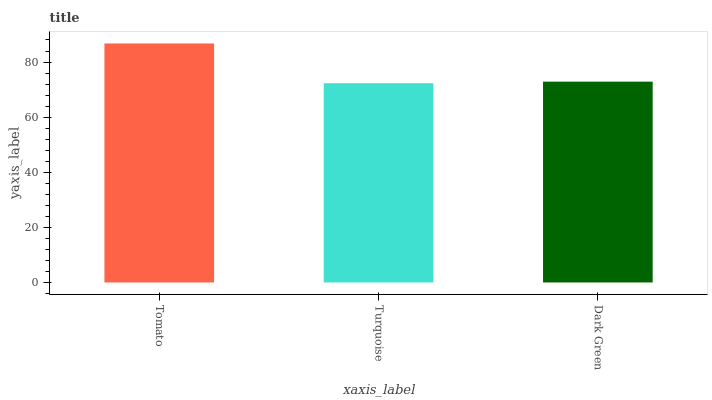Is Tomato the maximum?
Answer yes or no. Yes. Is Dark Green the minimum?
Answer yes or no. No. Is Dark Green the maximum?
Answer yes or no. No. Is Dark Green greater than Turquoise?
Answer yes or no. Yes. Is Turquoise less than Dark Green?
Answer yes or no. Yes. Is Turquoise greater than Dark Green?
Answer yes or no. No. Is Dark Green less than Turquoise?
Answer yes or no. No. Is Dark Green the high median?
Answer yes or no. Yes. Is Dark Green the low median?
Answer yes or no. Yes. Is Tomato the high median?
Answer yes or no. No. Is Turquoise the low median?
Answer yes or no. No. 